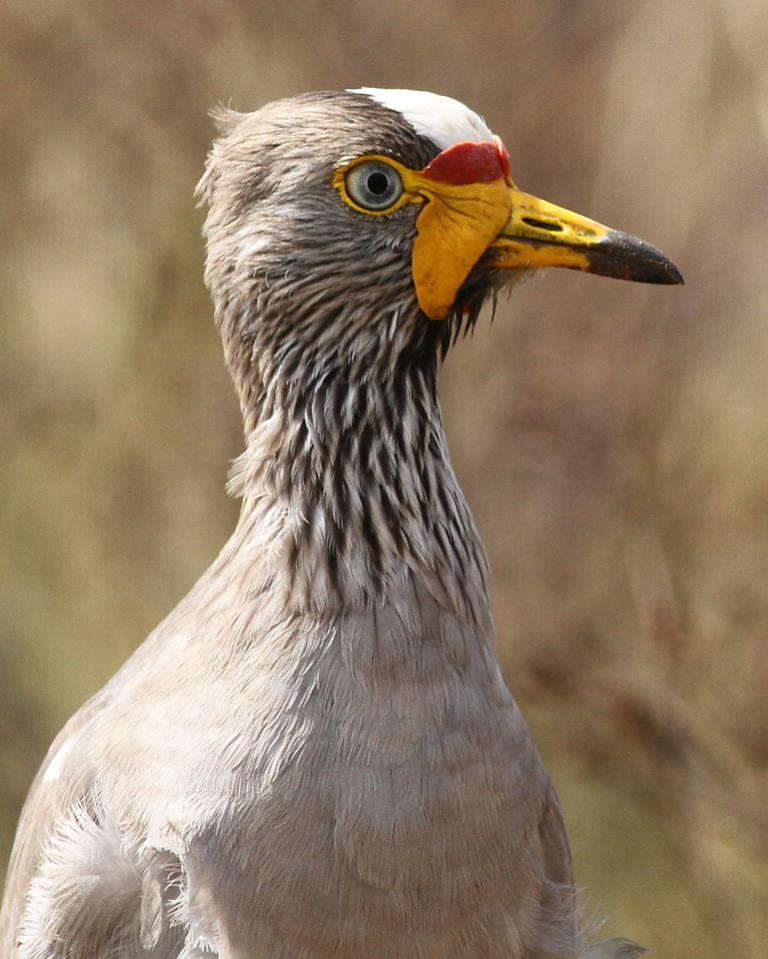What type of animal is in the image? There is a white color bird in the image. Where is the bird located in the image? The bird is in the front of the image. Can you describe the background of the image? The background of the image is blurred. How many cakes are being held by the babies in the image? There are no babies or cakes present in the image; it features a white color bird in the front with a blurred background. 